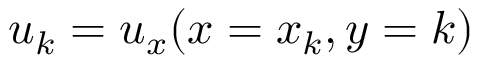<formula> <loc_0><loc_0><loc_500><loc_500>u _ { k } = u _ { x } ( x = x _ { k } , y = k )</formula> 